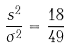<formula> <loc_0><loc_0><loc_500><loc_500>\frac { s ^ { 2 } } { \sigma ^ { 2 } } = \frac { 1 8 } { 4 9 }</formula> 